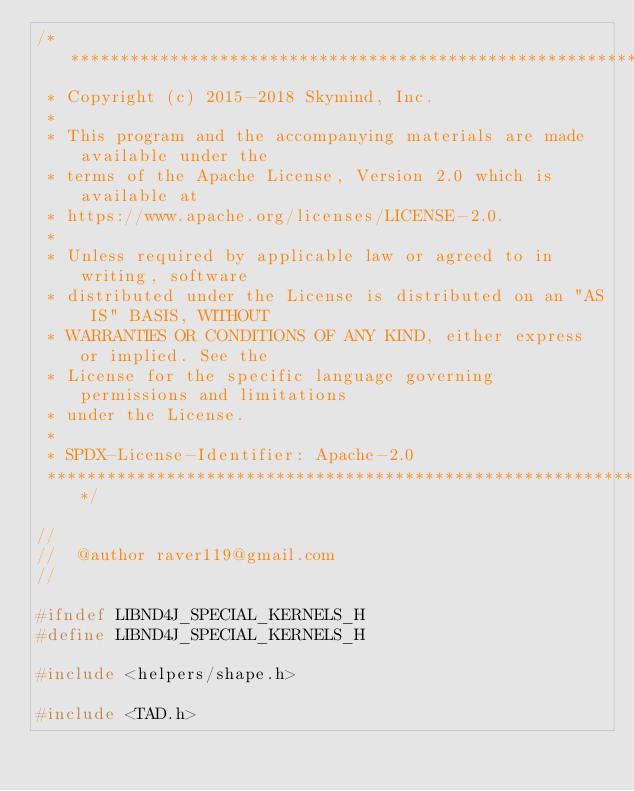<code> <loc_0><loc_0><loc_500><loc_500><_C_>/*******************************************************************************
 * Copyright (c) 2015-2018 Skymind, Inc.
 *
 * This program and the accompanying materials are made available under the
 * terms of the Apache License, Version 2.0 which is available at
 * https://www.apache.org/licenses/LICENSE-2.0.
 *
 * Unless required by applicable law or agreed to in writing, software
 * distributed under the License is distributed on an "AS IS" BASIS, WITHOUT
 * WARRANTIES OR CONDITIONS OF ANY KIND, either express or implied. See the
 * License for the specific language governing permissions and limitations
 * under the License.
 *
 * SPDX-License-Identifier: Apache-2.0
 ******************************************************************************/

//
//  @author raver119@gmail.com
//

#ifndef LIBND4J_SPECIAL_KERNELS_H
#define LIBND4J_SPECIAL_KERNELS_H

#include <helpers/shape.h>

#include <TAD.h></code> 